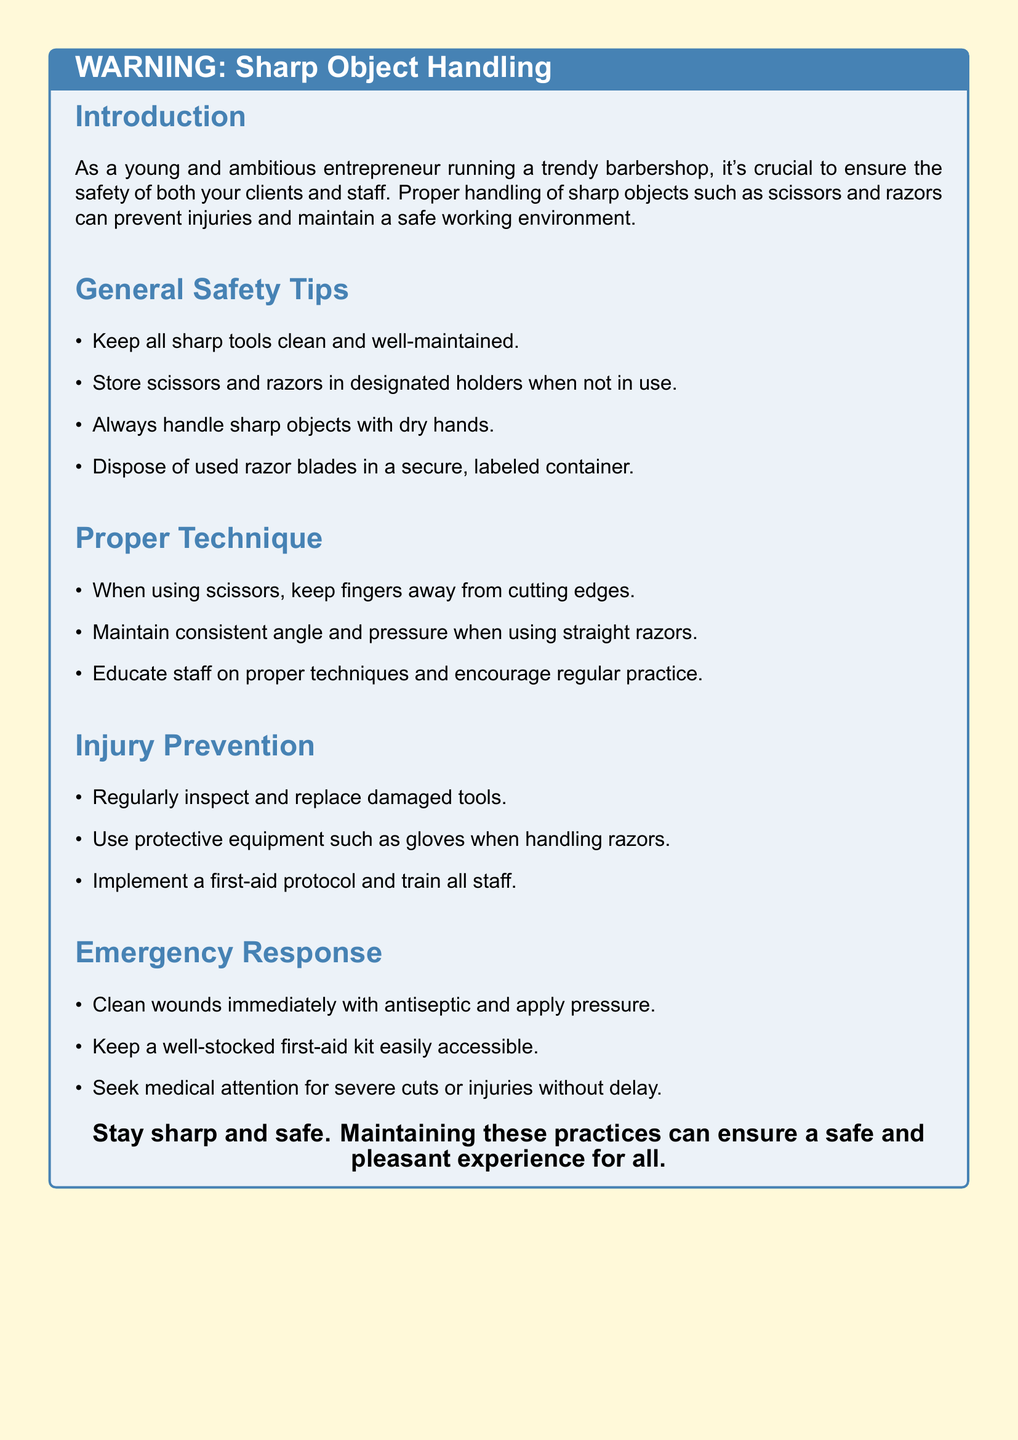what is the title of the warning label? The title is prominently displayed at the top of the document, indicating the main topic covered.
Answer: WARNING: Sharp Object Handling what color is used for the page background? The document specifies a light color for the background to enhance readability and emphasize the warning.
Answer: warningyellow how should scissors be stored when not in use? The document provides clear instructions on the proper storage of sharp tools to prevent accidents.
Answer: designated holders what protective equipment should be used when handling razors? This question pertains to specific safety measures highlighted in the document to prevent injuries.
Answer: gloves what should be done with used razor blades? The document emphasizes the importance of proper disposal methods for safety.
Answer: secure, labeled container how often should tools be inspected and replaced? This question involves preventative measures mentioned in the document for maintaining safety standards.
Answer: regularly what is recommended for cleaning wounds? The document advises a specific practice for managing injuries, focusing on immediate response measures.
Answer: antiseptic what should you do for severe cuts or injuries? This question relates to emergency procedures outlined in the document for handling serious situations.
Answer: Seek medical attention who should be trained in the first-aid protocol? The document suggests safety measures and the importance of training staff in emergencies.
Answer: all staff 